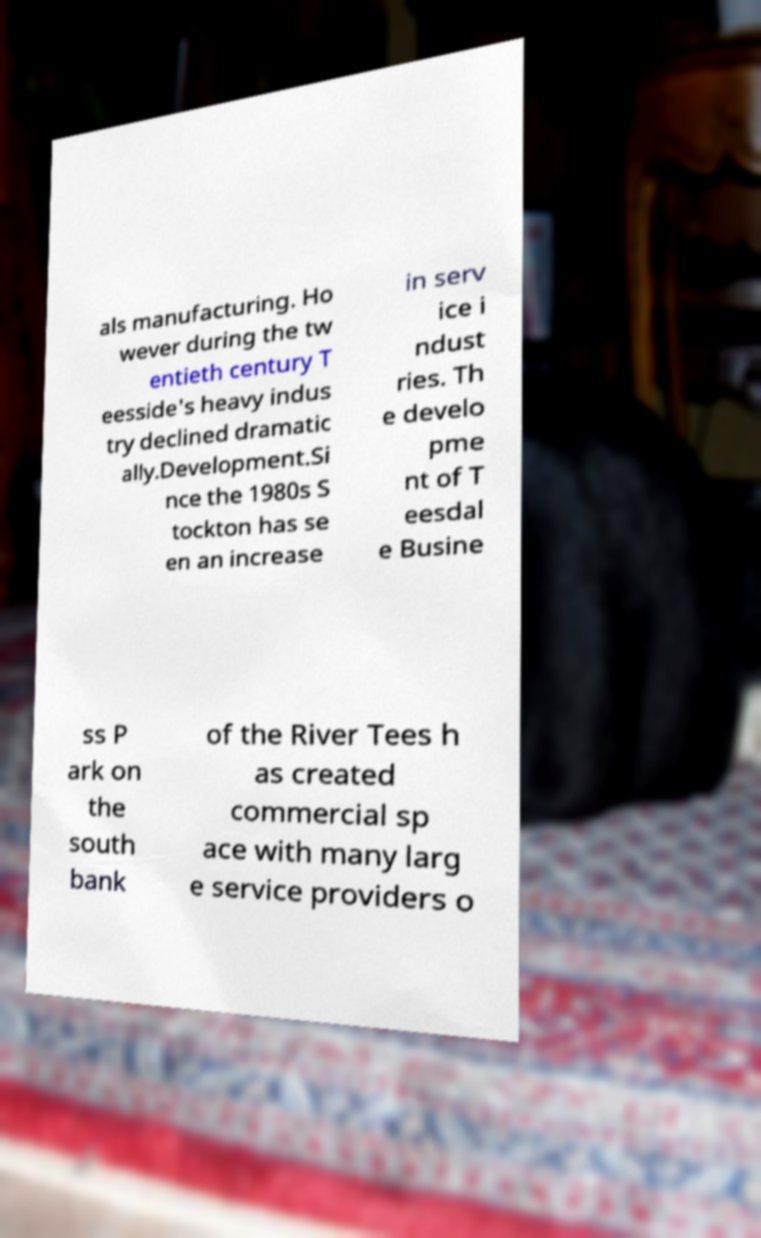There's text embedded in this image that I need extracted. Can you transcribe it verbatim? als manufacturing. Ho wever during the tw entieth century T eesside's heavy indus try declined dramatic ally.Development.Si nce the 1980s S tockton has se en an increase in serv ice i ndust ries. Th e develo pme nt of T eesdal e Busine ss P ark on the south bank of the River Tees h as created commercial sp ace with many larg e service providers o 